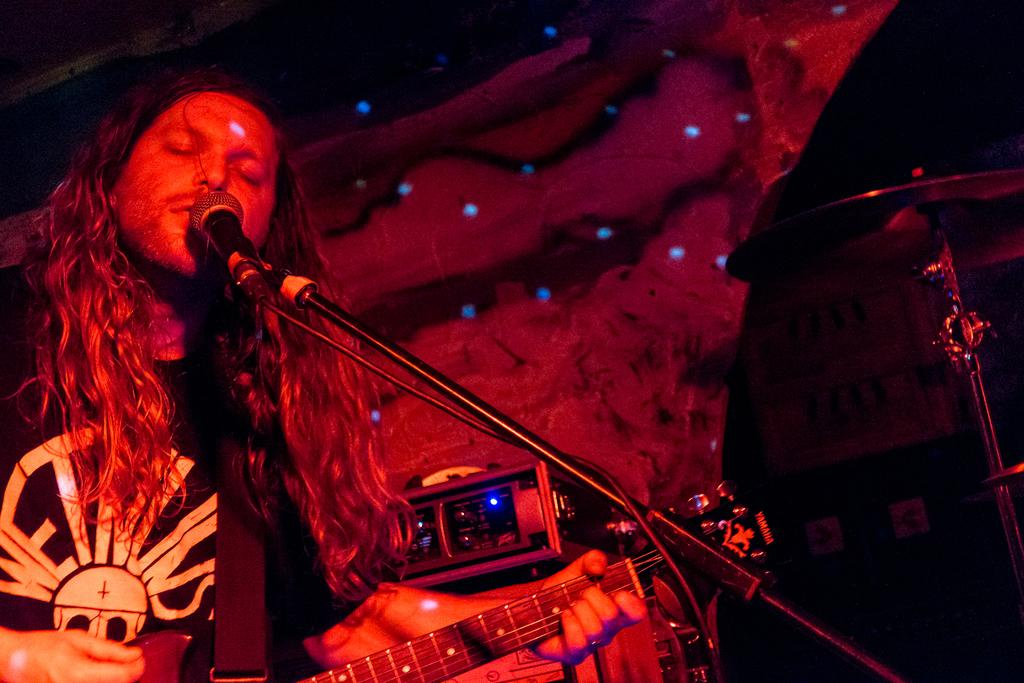What is the main subject of the image? There is a person in the image. What is the person doing in the image? The person is standing and playing a musical instrument. What type of vase is being used to sort items in the image? There is no vase or sorting activity present in the image; it features a person standing and playing a musical instrument. 